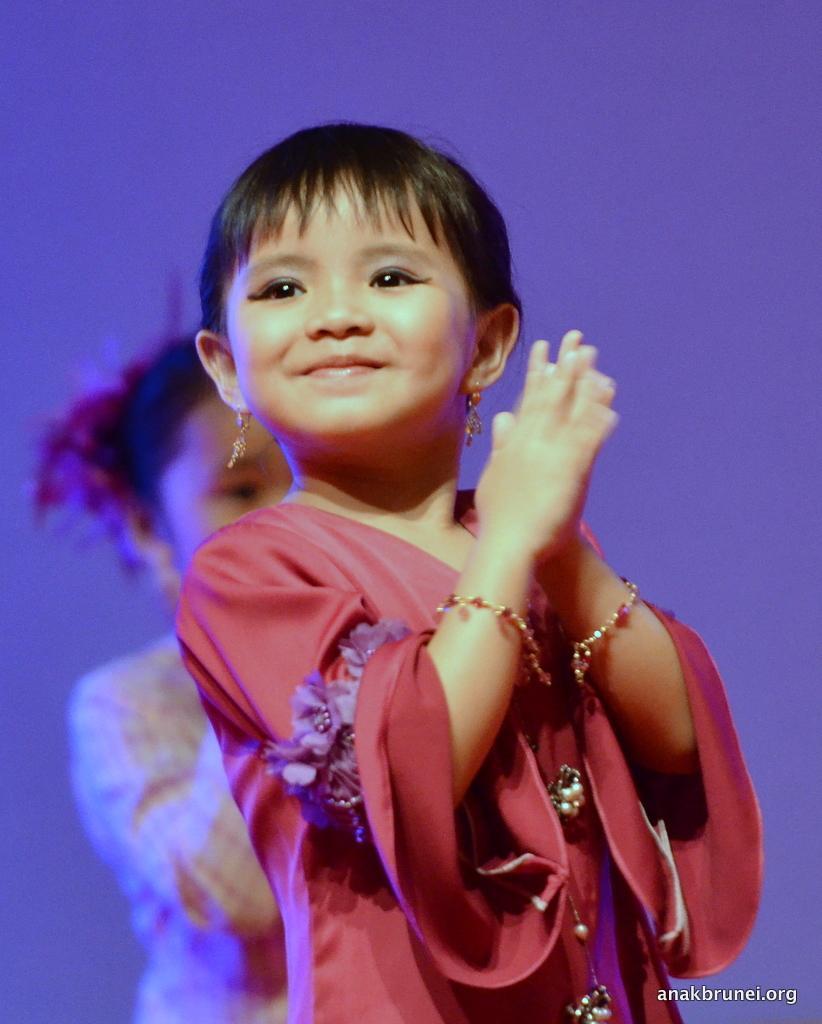Describe this image in one or two sentences. In this image we can see there is a girl with a smile on her face, behind this girl there is another girl. 